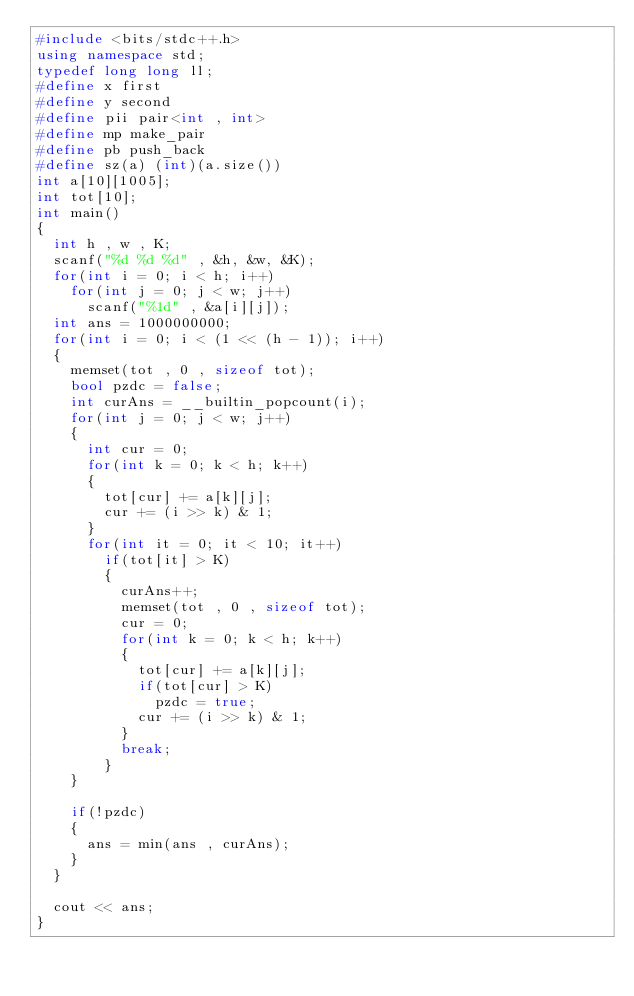<code> <loc_0><loc_0><loc_500><loc_500><_C++_>#include <bits/stdc++.h>
using namespace std;
typedef long long ll;
#define x first
#define y second
#define pii pair<int , int>
#define mp make_pair
#define pb push_back
#define sz(a) (int)(a.size())
int a[10][1005];
int tot[10];
int main()
{
	int h , w , K;
	scanf("%d %d %d" , &h, &w, &K);
	for(int i = 0; i < h; i++)
		for(int j = 0; j < w; j++)
			scanf("%1d" , &a[i][j]);
	int ans = 1000000000;
	for(int i = 0; i < (1 << (h - 1)); i++)
	{
		memset(tot , 0 , sizeof tot);
		bool pzdc = false;
		int curAns = __builtin_popcount(i);
		for(int j = 0; j < w; j++)
		{
			int cur = 0;
			for(int k = 0; k < h; k++)
			{
				tot[cur] += a[k][j];
				cur += (i >> k) & 1;
			}
			for(int it = 0; it < 10; it++)
				if(tot[it] > K)
				{
					curAns++;
					memset(tot , 0 , sizeof tot);
					cur = 0;
					for(int k = 0; k < h; k++)
					{
						tot[cur] += a[k][j];
						if(tot[cur] > K)
							pzdc = true;
						cur += (i >> k) & 1;
					}
					break;
				}
		}
		
		if(!pzdc)
		{
			ans = min(ans , curAns);
		}
	}
	
	cout << ans;
}
</code> 